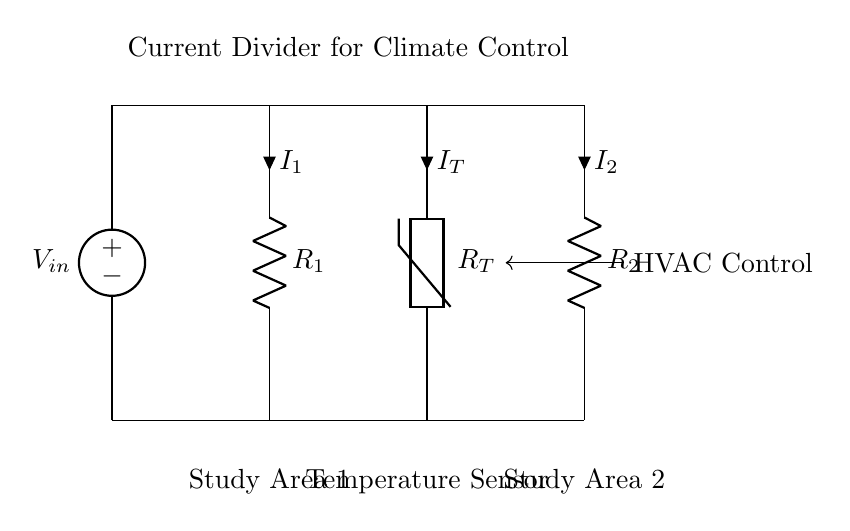What is the input voltage of the circuit? The input voltage is indicated on the left side of the circuit diagram as V_in. It is the source voltage provided to the circuit.
Answer: V_in What components are used in this current divider? The current divider consists of two resistors (R1 and R2) and a thermistor (RT). These components are connected in a way that divides the current.
Answer: R1, R2, RT Which study area is associated with the thermistor? The thermistor is located between Study Area 1 and Study Area 2, serving as a temperature sensor for climate control in both areas.
Answer: Both Study Areas What currents are represented in the circuit? The circuit diagram specifies three currents: I1 through R1, IT through the thermistor RT, and I2 through R2. Each is labeled adjacent to its respective component.
Answer: I1, IT, I2 What is the purpose of this current divider circuit? The purpose of the current divider circuit is to regulate the HVAC system based on temperature readings from the thermistor, aiding in climate control for various study areas.
Answer: Climate control How does the thermistor influence current flow in the circuit? The thermistor's resistance changes with temperature, which alters the distribution of current I1 and I2 between the resistors R1 and R2. This variability allows the HVAC system to respond to temperature changes effectively.
Answer: Current distribution 